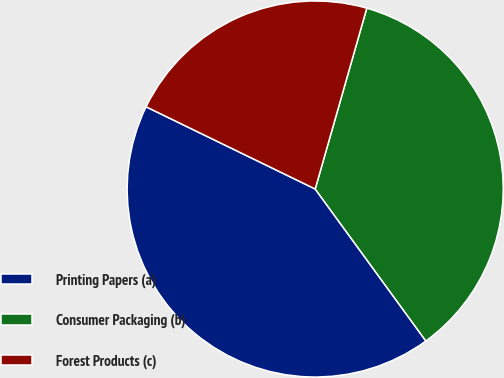Convert chart. <chart><loc_0><loc_0><loc_500><loc_500><pie_chart><fcel>Printing Papers (a)<fcel>Consumer Packaging (b)<fcel>Forest Products (c)<nl><fcel>42.22%<fcel>35.56%<fcel>22.22%<nl></chart> 